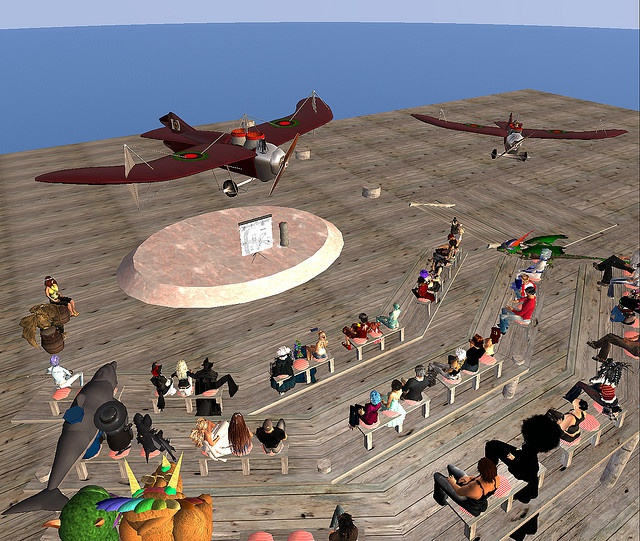Describe the objects in this image and their specific colors. I can see people in lavender, black, and gray tones, airplane in lavender, maroon, black, and gray tones, people in lavender, black, maroon, darkgray, and gray tones, airplane in lavender, maroon, black, and gray tones, and bench in lavender, darkgray, tan, and lightgray tones in this image. 